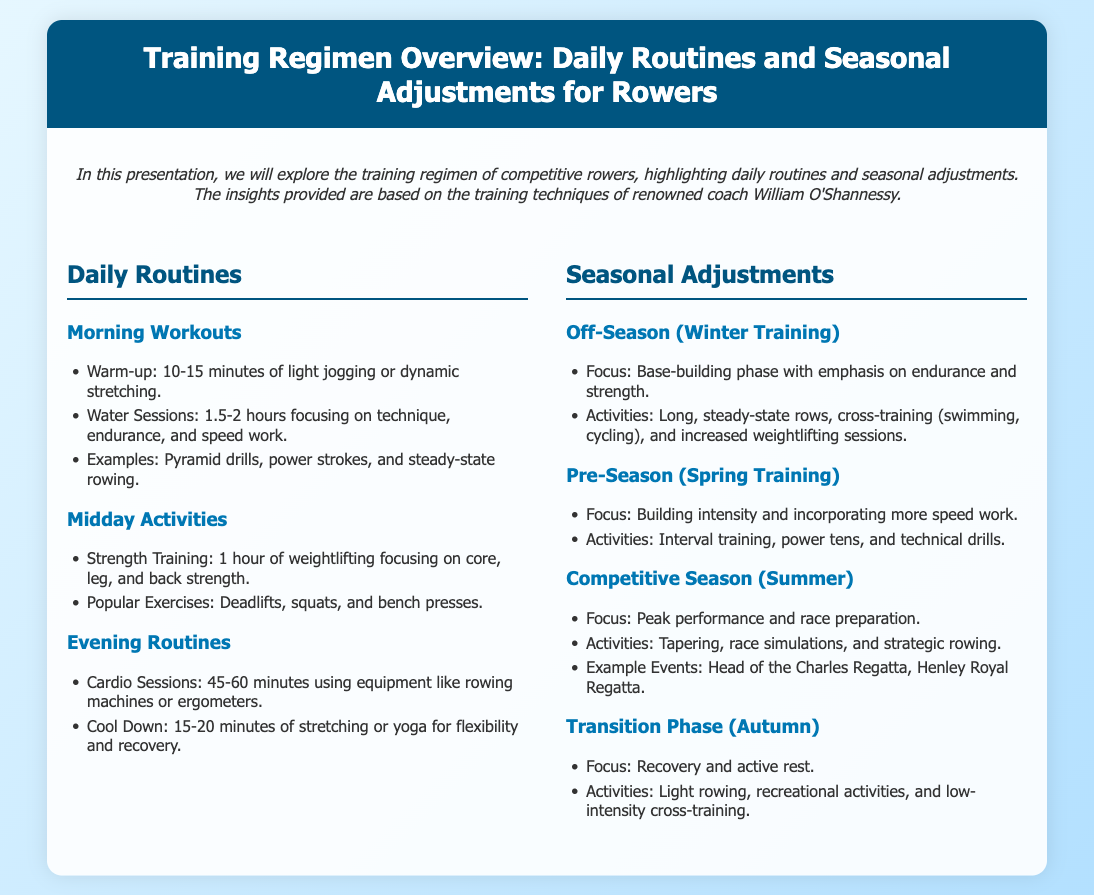What is the morning warm-up duration? The morning warm-up duration is specified in the document as 10-15 minutes.
Answer: 10-15 minutes What is the focus during the off-season? The focus during the off-season, as stated in the document, is on base-building, endurance, and strength.
Answer: Base-building, endurance, and strength How long are midday strength training sessions? The document mentions midday strength training sessions last for 1 hour.
Answer: 1 hour What activities are included in the competitive season? The activities included in the competitive season are tapering, race simulations, and strategic rowing.
Answer: Tapering, race simulations, and strategic rowing What type of training is emphasized in the pre-season? The pre-season emphasizes building intensity and incorporating more speed work according to the document.
Answer: Building intensity and speed work What is a common exercise for midday strength training? A common exercise for midday strength training mentioned in the document is deadlifts.
Answer: Deadlifts What is the main focus during the transition phase? During the transition phase, the main focus is on recovery and active rest, as specified in the document.
Answer: Recovery and active rest What is the duration of evening cardio sessions? The evening cardio sessions last for 45-60 minutes according to the document.
Answer: 45-60 minutes 